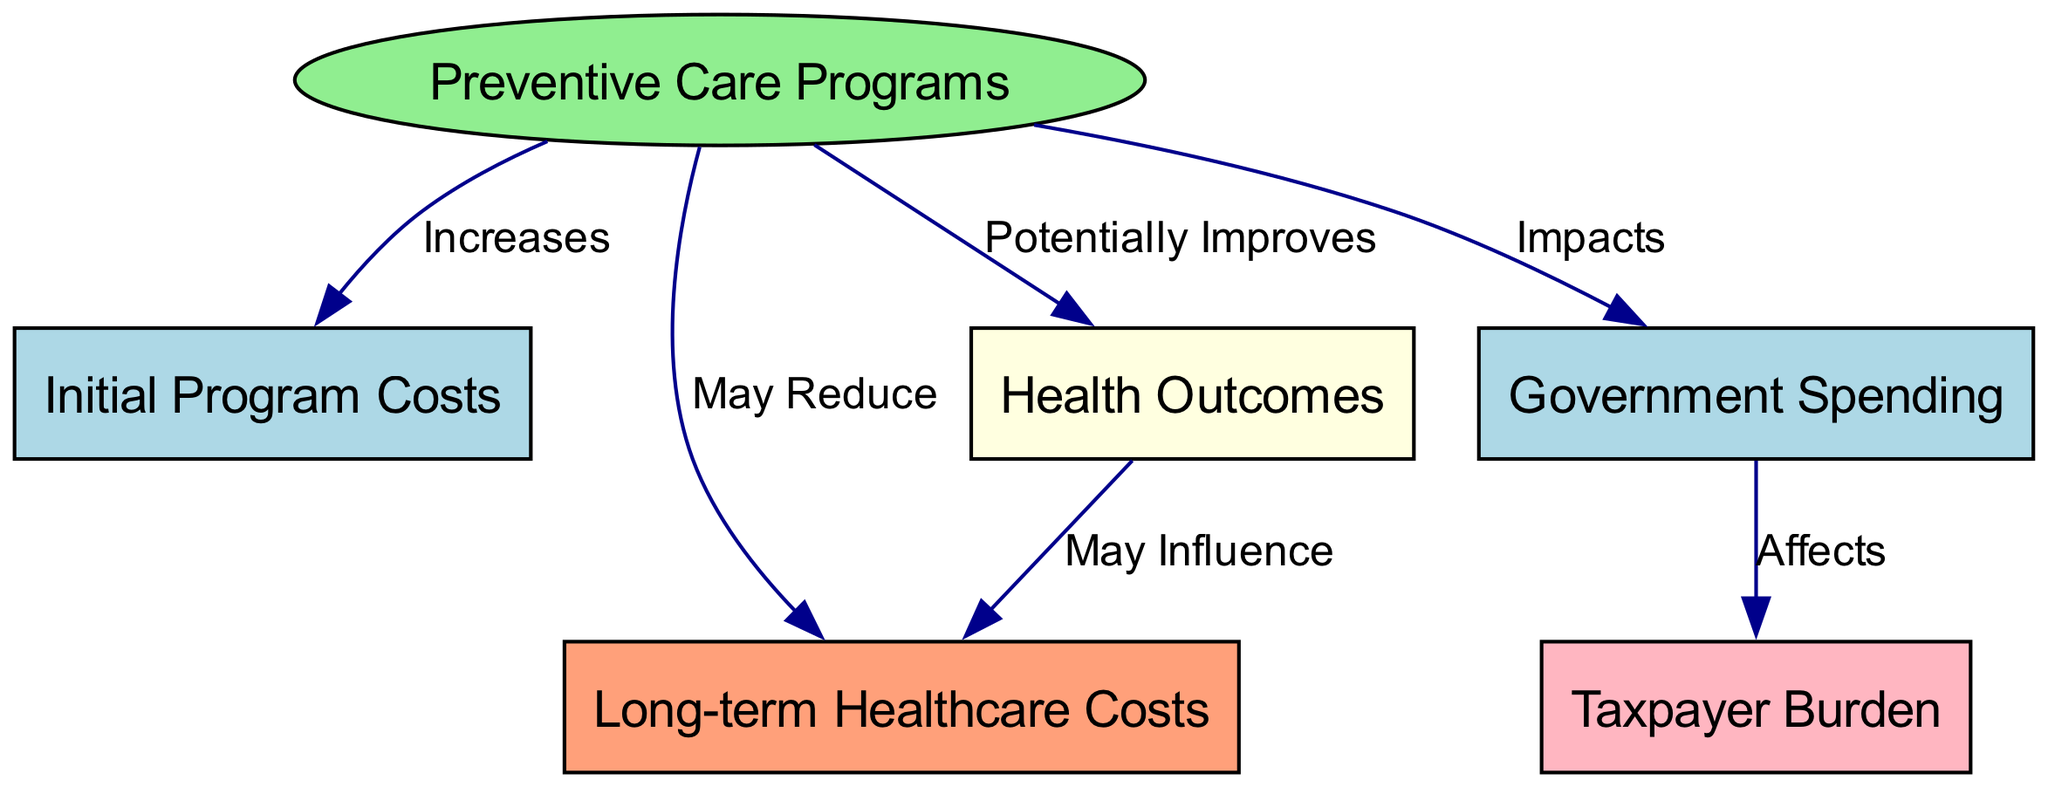What is the primary focus of the diagram? The primary focus of the diagram is on "Preventive Care Programs," which is the main node from which all other nodes are connected.
Answer: Preventive Care Programs How many nodes are present in the diagram? The diagram contains a total of six nodes: Preventive Care Programs, Initial Program Costs, Long-term Healthcare Costs, Government Spending, Taxpayer Burden, and Health Outcomes.
Answer: 6 What effect does "Preventive Care Programs" have on "Long-term Healthcare Costs"? The diagram indicates that "Preventive Care Programs" may reduce "Long-term Healthcare Costs," showing a potential positive impact.
Answer: May Reduce Which node is directly affected by "Government Spending"? "Government Spending" directly affects "Taxpayer Burden," indicating a relationship where changes in government spending will influence taxpayer obligations.
Answer: Taxpayer Burden How does "Health Outcomes" relate to "Long-term Healthcare Costs"? "Health Outcomes" may influence "Long-term Healthcare Costs," suggesting that improvements in health may lead to reduced costs in the long run.
Answer: May Influence What is the relationship between "Preventive Care Programs" and "Initial Program Costs"? The relationship is that "Preventive Care Programs" increases "Initial Program Costs," indicating that implementing these programs requires an upfront financial investment.
Answer: Increases What color represents "Health Outcomes" in this diagram? "Health Outcomes" is represented by the color light yellow in the diagram, which visually distinguishes it from other nodes.
Answer: Light yellow In total, how many edges are there in the diagram? The diagram has a total of six edges connecting the nodes, reflecting the various relationships and interactions among the elements.
Answer: 6 